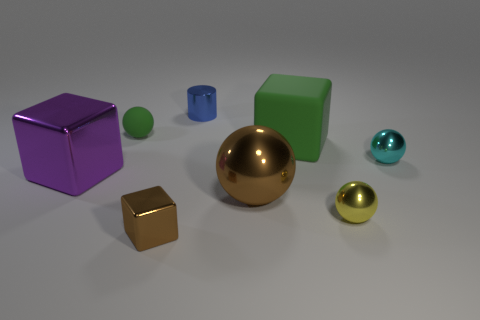Add 1 tiny metallic cubes. How many objects exist? 9 Subtract all cylinders. How many objects are left? 7 Subtract all big cyan cylinders. Subtract all tiny cyan spheres. How many objects are left? 7 Add 2 green rubber objects. How many green rubber objects are left? 4 Add 1 big cylinders. How many big cylinders exist? 1 Subtract 1 brown blocks. How many objects are left? 7 